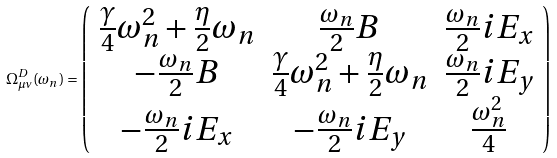<formula> <loc_0><loc_0><loc_500><loc_500>\Omega _ { \mu \nu } ^ { D } ( \omega _ { n } ) = \left ( \begin{array} { c c c } \frac { \gamma } { 4 } \omega _ { n } ^ { 2 } + \frac { \eta } { 2 } { \omega } _ { n } & \frac { \omega _ { n } } { 2 } B & \frac { \omega _ { n } } { 2 } i E _ { x } \\ - \frac { \omega _ { n } } { 2 } B & \frac { \gamma } { 4 } \omega _ { n } ^ { 2 } + \frac { \eta } { 2 } { \omega } _ { n } & \frac { \omega _ { n } } { 2 } i E _ { y } \\ - \frac { \omega _ { n } } { 2 } i E _ { x } & - \frac { \omega _ { n } } { 2 } i E _ { y } & \frac { \omega _ { n } ^ { 2 } } { 4 } \\ \end{array} \right )</formula> 